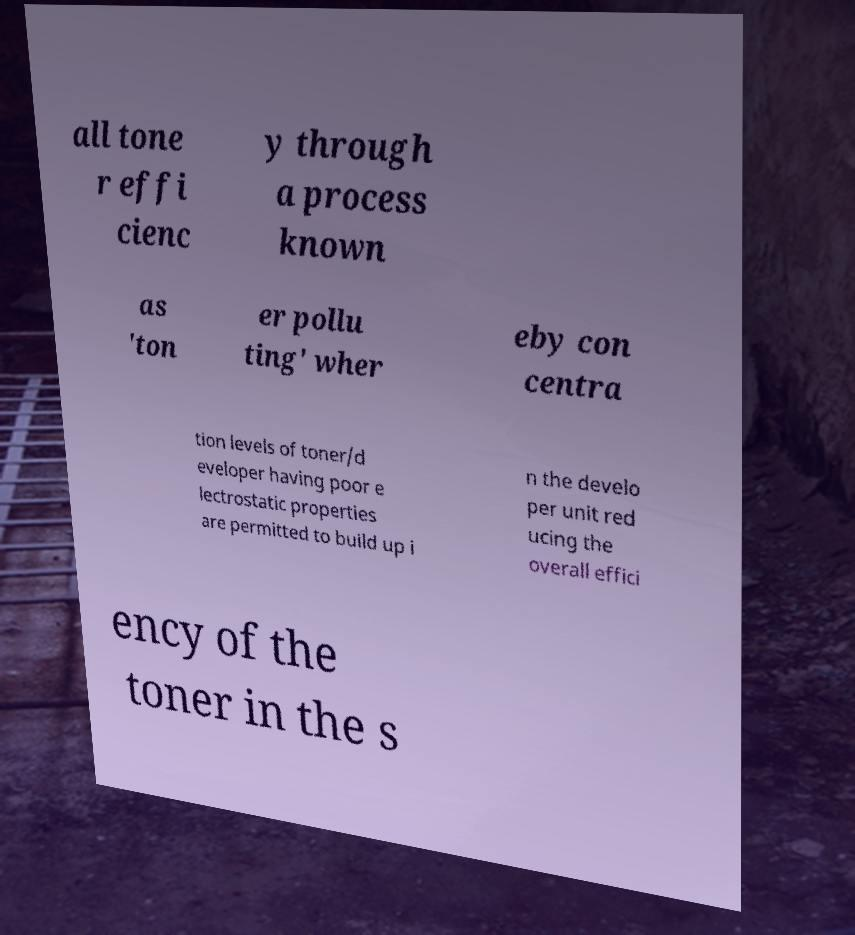What messages or text are displayed in this image? I need them in a readable, typed format. all tone r effi cienc y through a process known as 'ton er pollu ting' wher eby con centra tion levels of toner/d eveloper having poor e lectrostatic properties are permitted to build up i n the develo per unit red ucing the overall effici ency of the toner in the s 